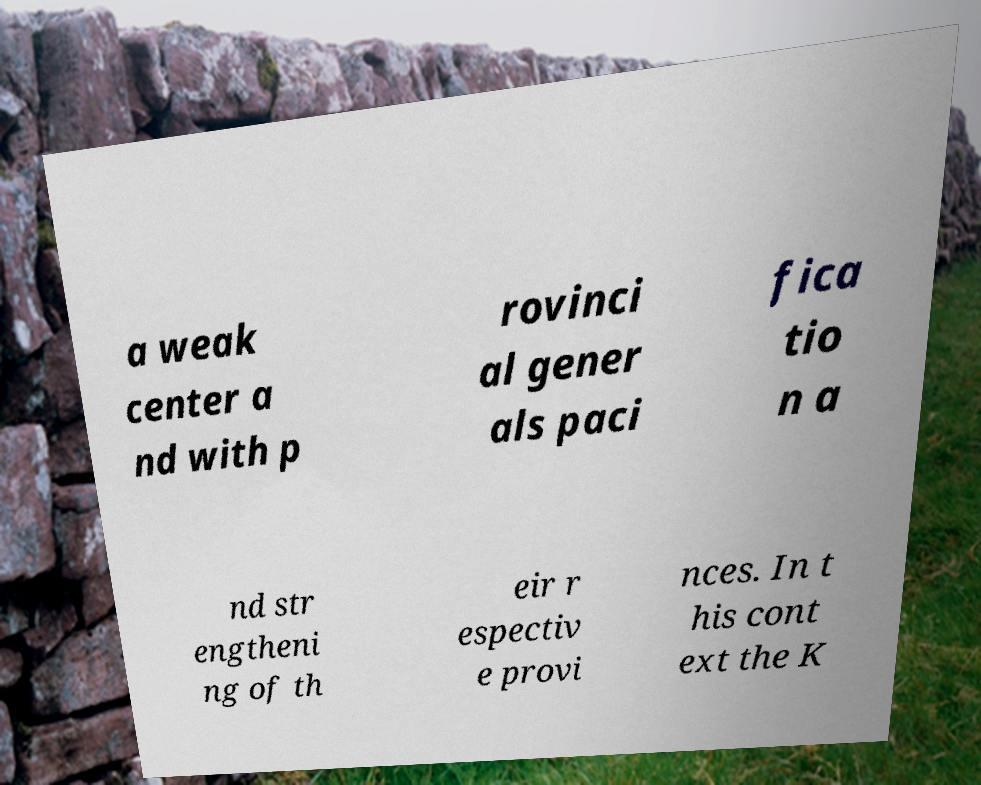What messages or text are displayed in this image? I need them in a readable, typed format. a weak center a nd with p rovinci al gener als paci fica tio n a nd str engtheni ng of th eir r espectiv e provi nces. In t his cont ext the K 